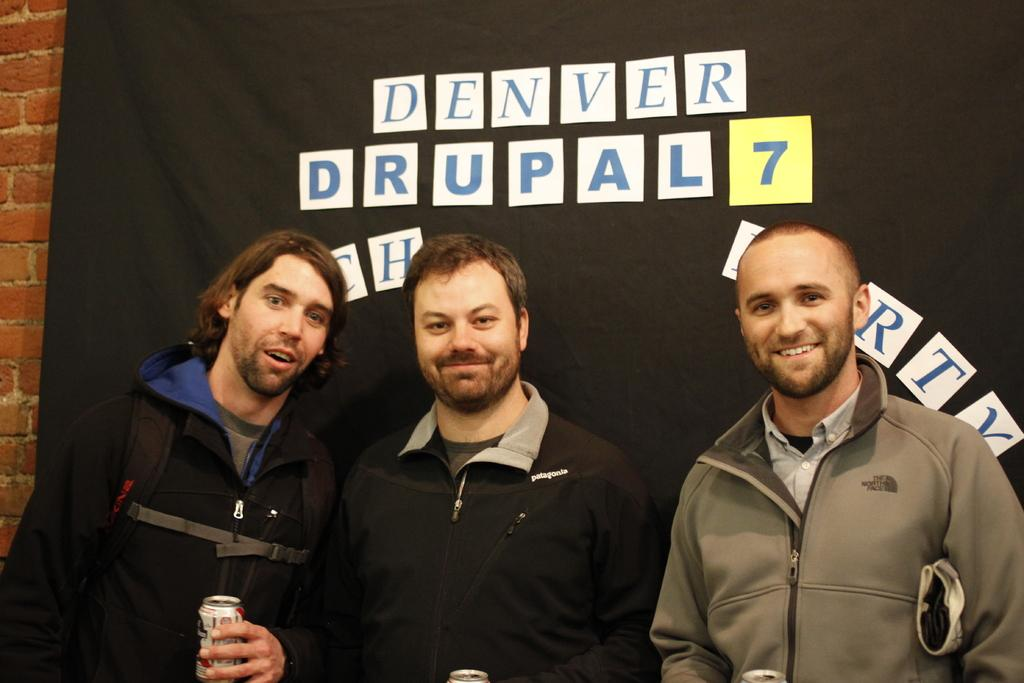Provide a one-sentence caption for the provided image. Three men pose in front of a Denver Drupal 7 backdrop. 